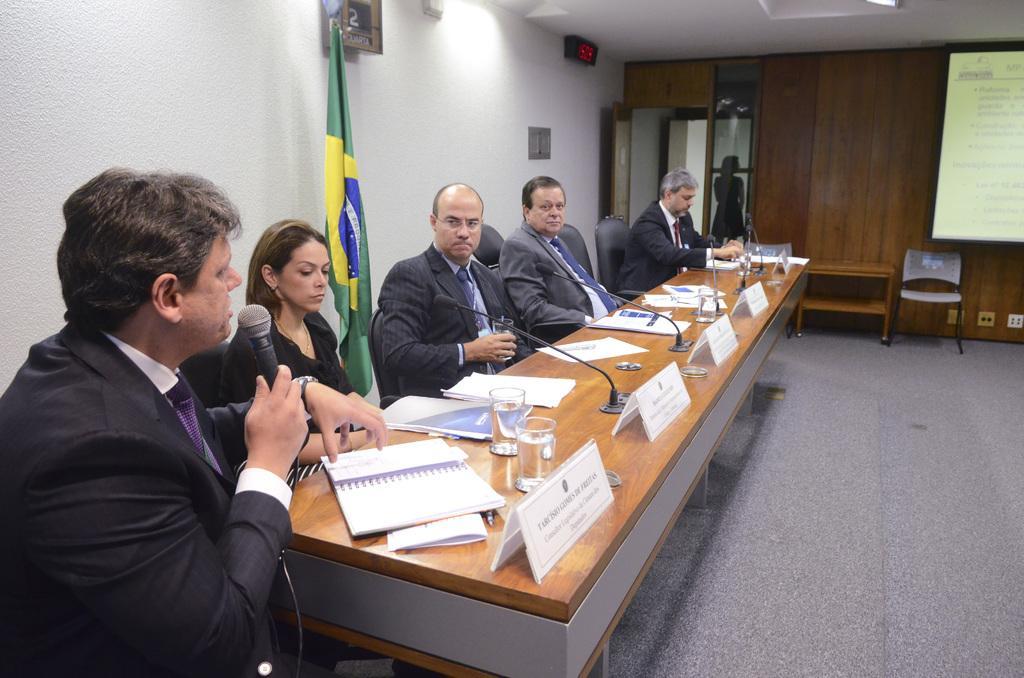In one or two sentences, can you explain what this image depicts? In this image on the right side, I can see some text projected on the screen. On the left side I can see some people are sitting on the chairs. I can see some objects on the table. I can see a flag. In the background, I can see a door, a chair and a table. I can also see a person standing. 